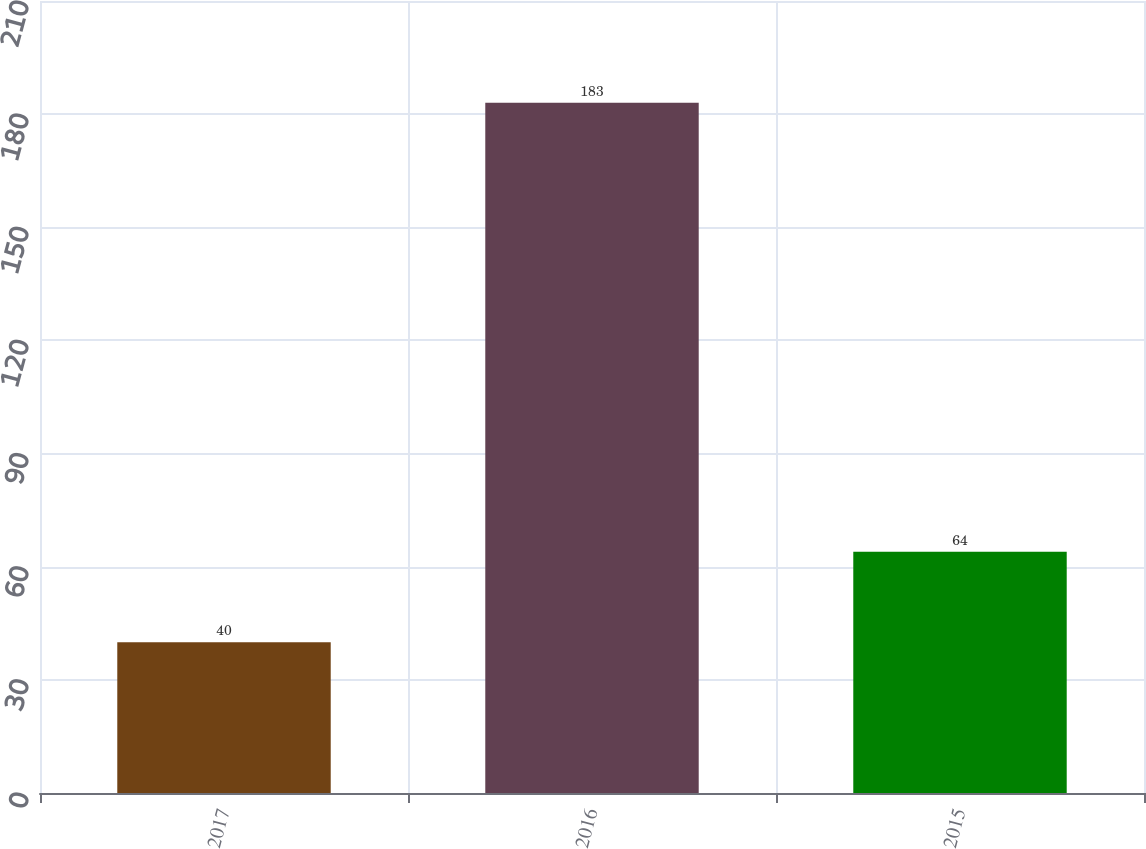Convert chart. <chart><loc_0><loc_0><loc_500><loc_500><bar_chart><fcel>2017<fcel>2016<fcel>2015<nl><fcel>40<fcel>183<fcel>64<nl></chart> 